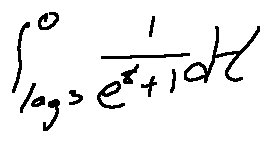<formula> <loc_0><loc_0><loc_500><loc_500>\int \lim i t s _ { \log 3 } ^ { 0 } \frac { 1 } { e ^ { t } + 1 } d t</formula> 